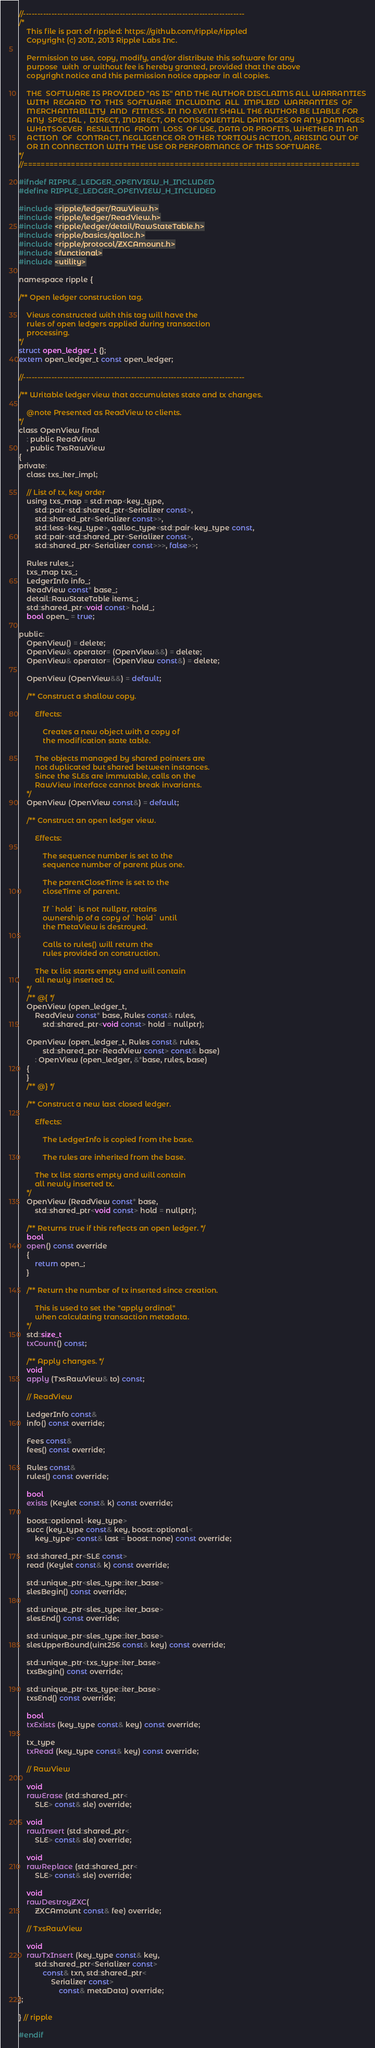Convert code to text. <code><loc_0><loc_0><loc_500><loc_500><_C_>//------------------------------------------------------------------------------
/*
    This file is part of rippled: https://github.com/ripple/rippled
    Copyright (c) 2012, 2013 Ripple Labs Inc.

    Permission to use, copy, modify, and/or distribute this software for any
    purpose  with  or without fee is hereby granted, provided that the above
    copyright notice and this permission notice appear in all copies.

    THE  SOFTWARE IS PROVIDED "AS IS" AND THE AUTHOR DISCLAIMS ALL WARRANTIES
    WITH  REGARD  TO  THIS  SOFTWARE  INCLUDING  ALL  IMPLIED  WARRANTIES  OF
    MERCHANTABILITY  AND  FITNESS. IN NO EVENT SHALL THE AUTHOR BE LIABLE FOR
    ANY  SPECIAL ,  DIRECT, INDIRECT, OR CONSEQUENTIAL DAMAGES OR ANY DAMAGES
    WHATSOEVER  RESULTING  FROM  LOSS  OF USE, DATA OR PROFITS, WHETHER IN AN
    ACTION  OF  CONTRACT, NEGLIGENCE OR OTHER TORTIOUS ACTION, ARISING OUT OF
    OR IN CONNECTION WITH THE USE OR PERFORMANCE OF THIS SOFTWARE.
*/
//==============================================================================

#ifndef RIPPLE_LEDGER_OPENVIEW_H_INCLUDED
#define RIPPLE_LEDGER_OPENVIEW_H_INCLUDED

#include <ripple/ledger/RawView.h>
#include <ripple/ledger/ReadView.h>
#include <ripple/ledger/detail/RawStateTable.h>
#include <ripple/basics/qalloc.h>
#include <ripple/protocol/ZXCAmount.h>
#include <functional>
#include <utility>

namespace ripple {

/** Open ledger construction tag.

    Views constructed with this tag will have the
    rules of open ledgers applied during transaction
    processing.
*/
struct open_ledger_t {};
extern open_ledger_t const open_ledger;

//------------------------------------------------------------------------------

/** Writable ledger view that accumulates state and tx changes.

    @note Presented as ReadView to clients.
*/
class OpenView final
    : public ReadView
    , public TxsRawView
{
private:
    class txs_iter_impl;

    // List of tx, key order
    using txs_map = std::map<key_type,
        std::pair<std::shared_ptr<Serializer const>,
        std::shared_ptr<Serializer const>>,
        std::less<key_type>, qalloc_type<std::pair<key_type const,
        std::pair<std::shared_ptr<Serializer const>,
        std::shared_ptr<Serializer const>>>, false>>;

    Rules rules_;
    txs_map txs_;
    LedgerInfo info_;
    ReadView const* base_;
    detail::RawStateTable items_;
    std::shared_ptr<void const> hold_;
    bool open_ = true;

public:
    OpenView() = delete;
    OpenView& operator= (OpenView&&) = delete;
    OpenView& operator= (OpenView const&) = delete;

    OpenView (OpenView&&) = default;

    /** Construct a shallow copy.

        Effects:

            Creates a new object with a copy of
            the modification state table.

        The objects managed by shared pointers are
        not duplicated but shared between instances.
        Since the SLEs are immutable, calls on the
        RawView interface cannot break invariants.
    */
    OpenView (OpenView const&) = default;

    /** Construct an open ledger view.

        Effects:

            The sequence number is set to the
            sequence number of parent plus one.

            The parentCloseTime is set to the
            closeTime of parent.

            If `hold` is not nullptr, retains
            ownership of a copy of `hold` until
            the MetaView is destroyed.

            Calls to rules() will return the
            rules provided on construction.

        The tx list starts empty and will contain
        all newly inserted tx.
    */
    /** @{ */
    OpenView (open_ledger_t,
        ReadView const* base, Rules const& rules,
            std::shared_ptr<void const> hold = nullptr);

    OpenView (open_ledger_t, Rules const& rules,
            std::shared_ptr<ReadView const> const& base)
        : OpenView (open_ledger, &*base, rules, base)
    {
    }
    /** @} */

    /** Construct a new last closed ledger.

        Effects:

            The LedgerInfo is copied from the base.

            The rules are inherited from the base.

        The tx list starts empty and will contain
        all newly inserted tx.
    */
    OpenView (ReadView const* base,
        std::shared_ptr<void const> hold = nullptr);

    /** Returns true if this reflects an open ledger. */
    bool
    open() const override
    {
        return open_;
    }

    /** Return the number of tx inserted since creation.

        This is used to set the "apply ordinal"
        when calculating transaction metadata.
    */
    std::size_t
    txCount() const;

    /** Apply changes. */
    void
    apply (TxsRawView& to) const;

    // ReadView

    LedgerInfo const&
    info() const override;

    Fees const&
    fees() const override;

    Rules const&
    rules() const override;

    bool
    exists (Keylet const& k) const override;

    boost::optional<key_type>
    succ (key_type const& key, boost::optional<
        key_type> const& last = boost::none) const override;

    std::shared_ptr<SLE const>
    read (Keylet const& k) const override;

    std::unique_ptr<sles_type::iter_base>
    slesBegin() const override;

    std::unique_ptr<sles_type::iter_base>
    slesEnd() const override;

    std::unique_ptr<sles_type::iter_base>
    slesUpperBound(uint256 const& key) const override;

    std::unique_ptr<txs_type::iter_base>
    txsBegin() const override;

    std::unique_ptr<txs_type::iter_base>
    txsEnd() const override;

    bool
    txExists (key_type const& key) const override;

    tx_type
    txRead (key_type const& key) const override;

    // RawView

    void
    rawErase (std::shared_ptr<
        SLE> const& sle) override;

    void
    rawInsert (std::shared_ptr<
        SLE> const& sle) override;

    void
    rawReplace (std::shared_ptr<
        SLE> const& sle) override;

    void
    rawDestroyZXC(
        ZXCAmount const& fee) override;

    // TxsRawView

    void
    rawTxInsert (key_type const& key,
        std::shared_ptr<Serializer const>
            const& txn, std::shared_ptr<
                Serializer const>
                    const& metaData) override;
};

} // ripple

#endif
</code> 